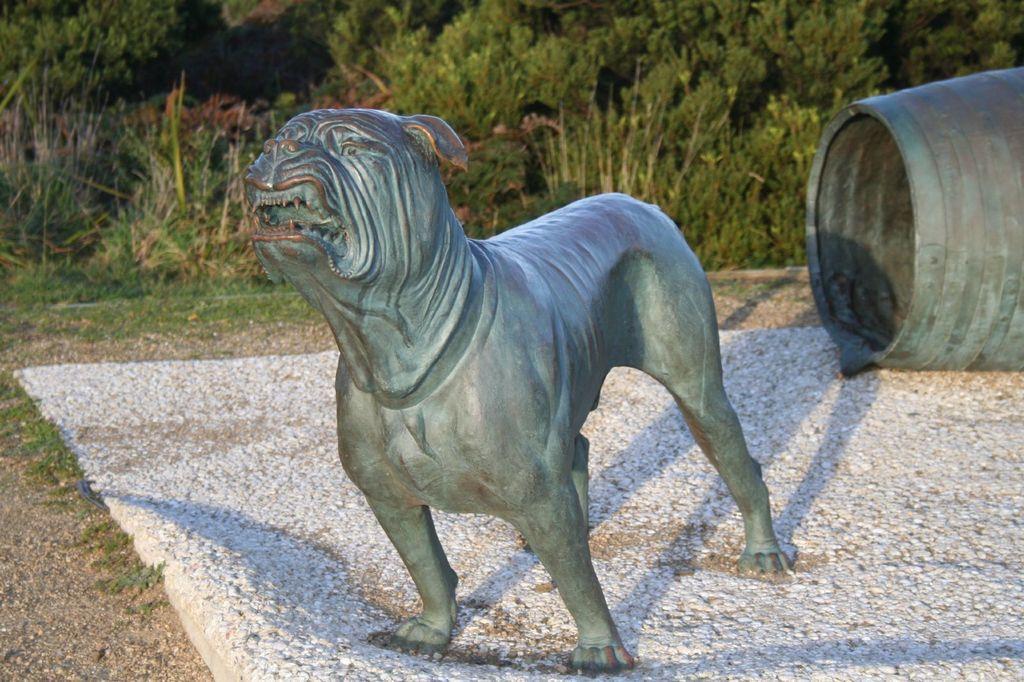Could you give a brief overview of what you see in this image? In this picture i can see the statue of a dog. At the bottom there is a barrel. In the background i can see trees, plants and grass. 